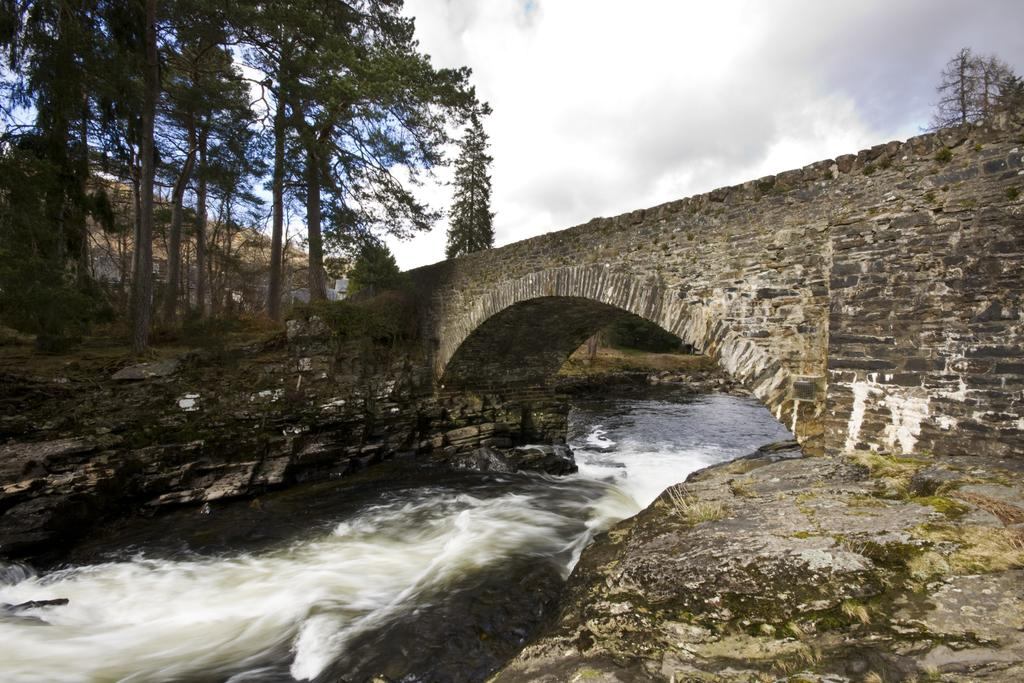What structure can be seen in the image? There is a bridge in the image. What is happening under the bridge? Water is flowing under the bridge. What type of vegetation is present in the image? There are trees in the image. What can be seen in the background of the image? The sky is visible in the background of the image. What is the condition of the sky in the image? There are clouds in the sky. Where is the cushion placed in the image? There is no cushion present in the image. What type of cakes are being served on the bridge in the image? There are no cakes present in the image; it features a bridge with water flowing underneath. 